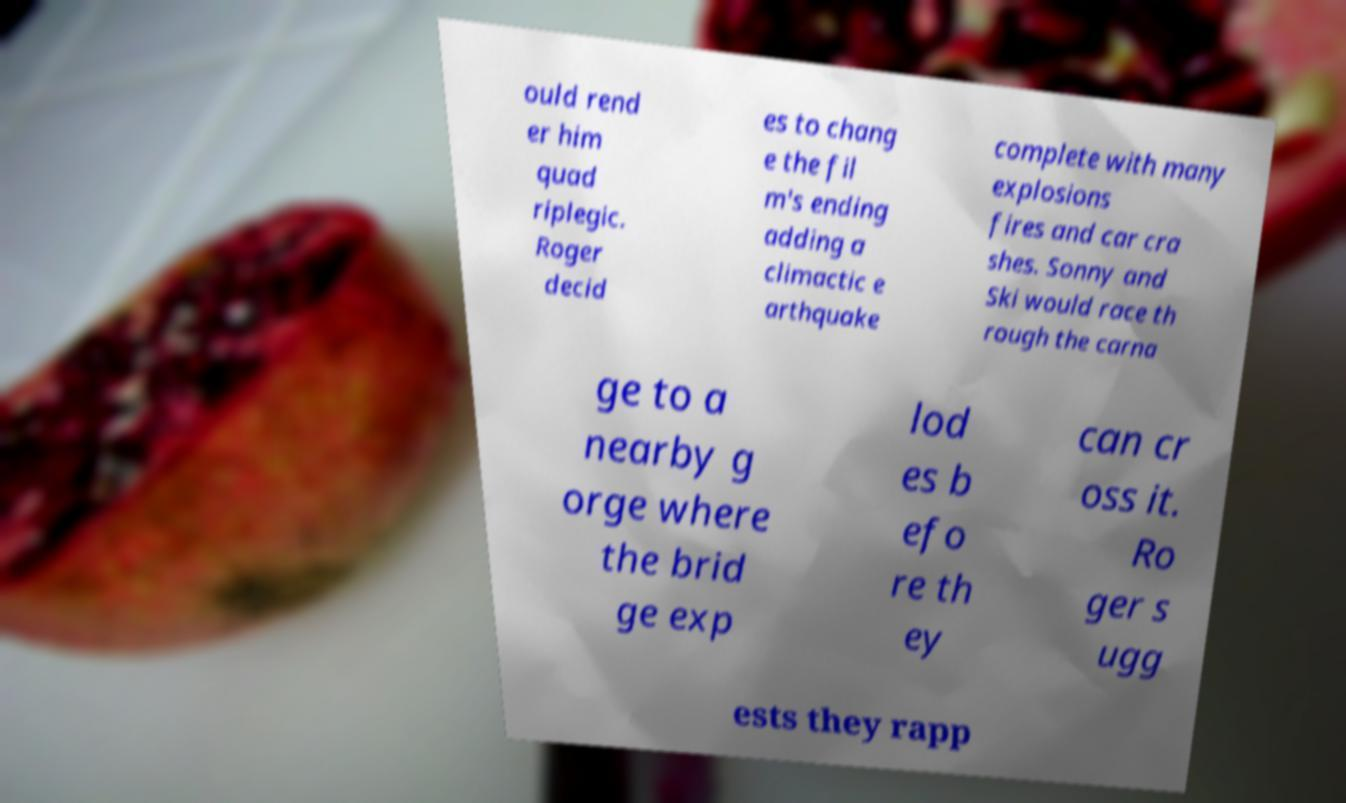Please read and relay the text visible in this image. What does it say? ould rend er him quad riplegic. Roger decid es to chang e the fil m's ending adding a climactic e arthquake complete with many explosions fires and car cra shes. Sonny and Ski would race th rough the carna ge to a nearby g orge where the brid ge exp lod es b efo re th ey can cr oss it. Ro ger s ugg ests they rapp 